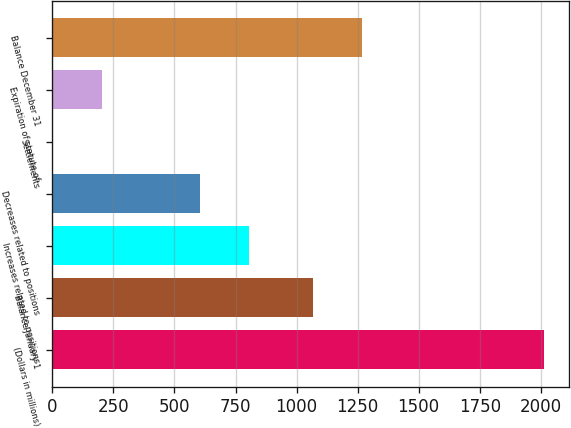<chart> <loc_0><loc_0><loc_500><loc_500><bar_chart><fcel>(Dollars in millions)<fcel>Balance January 1<fcel>Increases related to positions<fcel>Decreases related to positions<fcel>Settlements<fcel>Expiration of statute of<fcel>Balance December 31<nl><fcel>2015<fcel>1068<fcel>806.6<fcel>605.2<fcel>1<fcel>202.4<fcel>1269.4<nl></chart> 